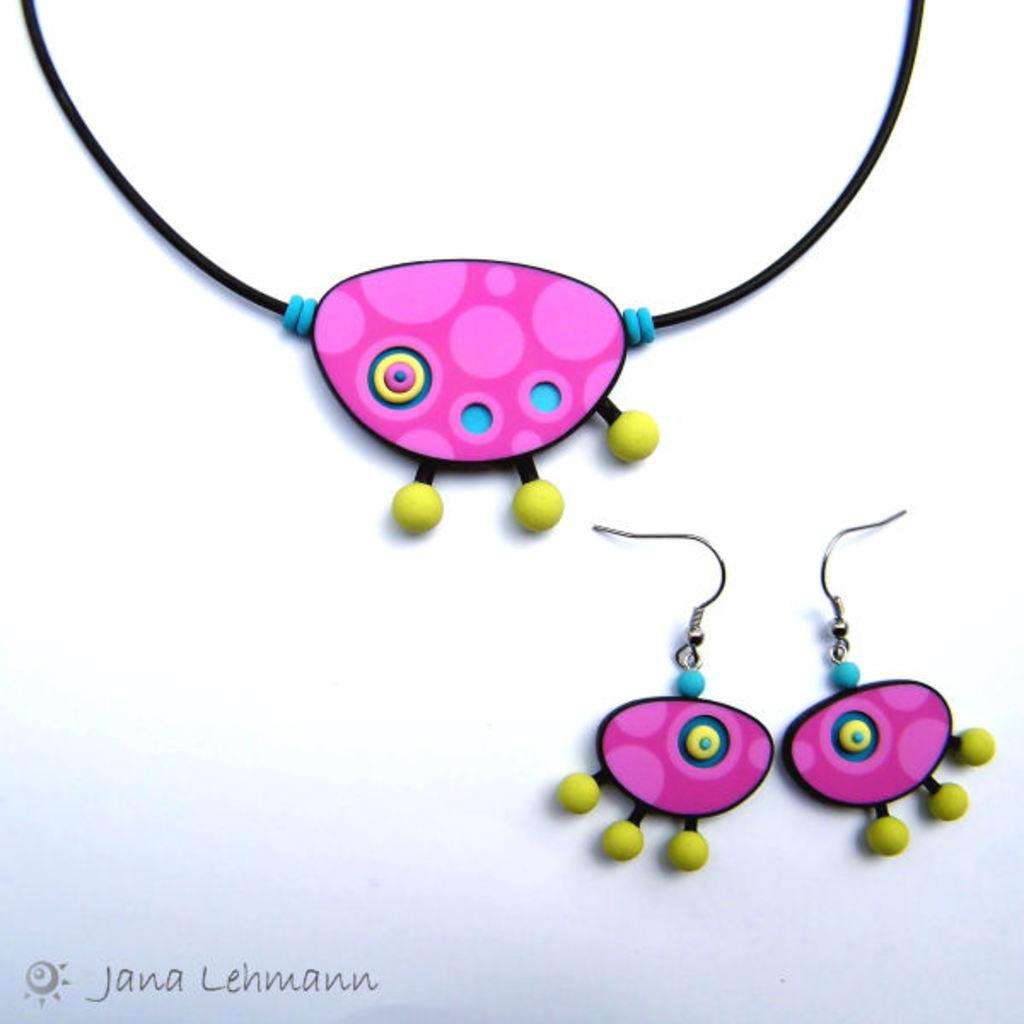What type of jewelry is visible in the image? There are earrings in the image. What other accessory can be seen in the image? There is a chain in the image. What color is the background of the image? The background of the image is white. Is there any text or logo visible in the image? Yes, there is a watermark in the bottom left corner of the image. How many apples are being used to answer the question in the image? A: There are no apples present in the image, and they are not being used to answer any questions. 